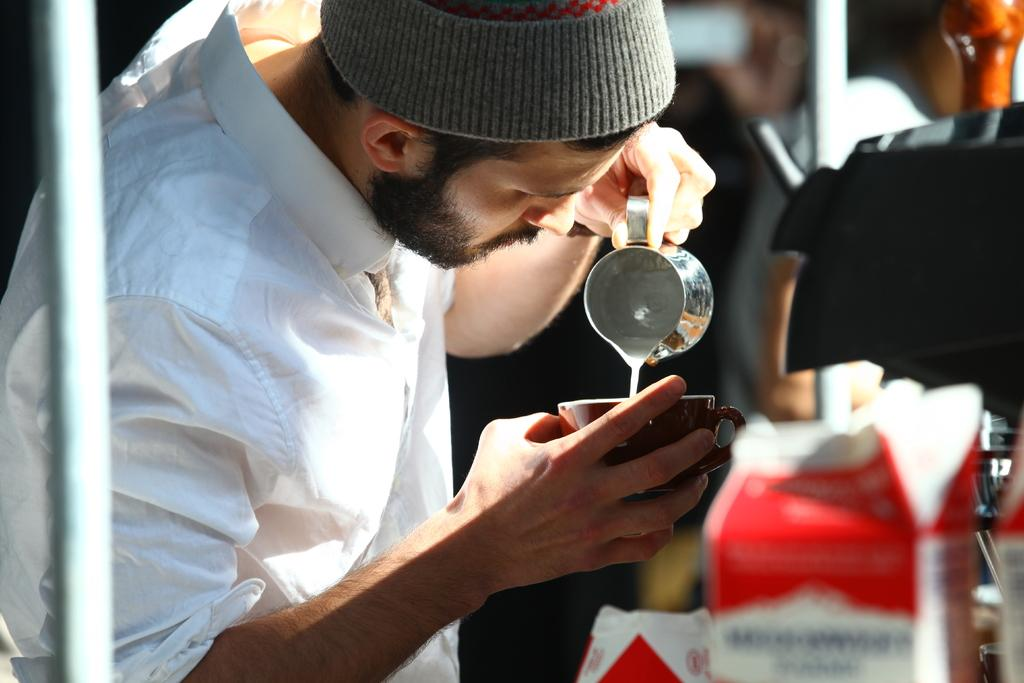Who is present in the image? There is a person in the image. What is the person holding in the image? The person is holding a cup. What is the person doing with the cup? The person is preparing a drink. What can be seen behind the person in the image? There are objects visible behind the person. What type of discovery did the person make while preparing the drink in the image? There is no indication of a discovery in the image; the person is simply preparing a drink. What type of iron is visible in the image? There is no iron present in the image. 